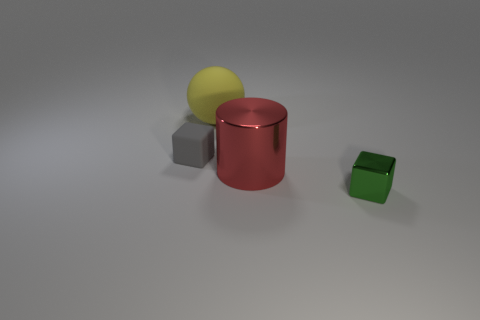Add 2 green metallic objects. How many objects exist? 6 Subtract 1 spheres. How many spheres are left? 0 Subtract all green blocks. How many blocks are left? 1 Subtract 0 red spheres. How many objects are left? 4 Subtract all cylinders. How many objects are left? 3 Subtract all blue balls. Subtract all purple cylinders. How many balls are left? 1 Subtract all brown blocks. How many cyan cylinders are left? 0 Subtract all big metal objects. Subtract all tiny red shiny cylinders. How many objects are left? 3 Add 1 big red cylinders. How many big red cylinders are left? 2 Add 4 rubber spheres. How many rubber spheres exist? 5 